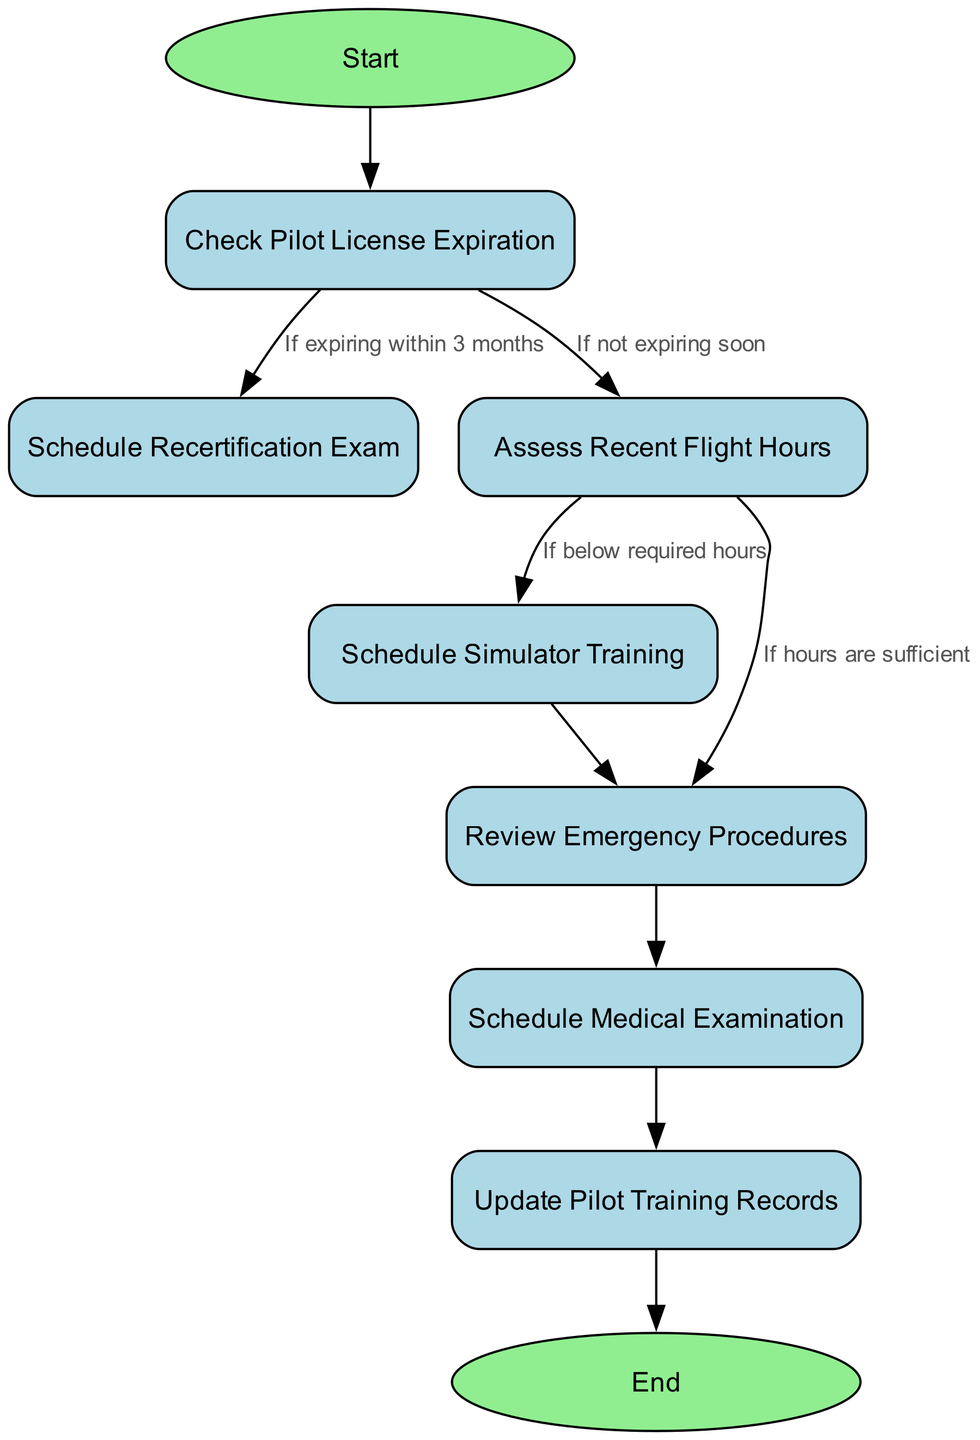What is the first step in the flowchart? The starting point of the flowchart is represented by the "Start" node, which indicates the initiation of the pilot recertification and ongoing training program scheduling process.
Answer: Start How many nodes are in the diagram? By counting all the nodes including the start and end nodes, there are a total of nine nodes in the diagram.
Answer: Nine What does the "Check Pilot License Expiration" node lead to if the license is expiring soon? If the pilot license is expiring soon, the next step to follow is the "Schedule Recertification Exam" node, based on the flow from the license check node.
Answer: Schedule Recertification Exam What is the outcome if the pilot has sufficient flight hours? If the pilot has sufficient flight hours, the process moves to the "Review Emergency Procedures" node without scheduling simulator training.
Answer: Review Emergency Procedures What is the last step of the flowchart? The final step of the flowchart, marked by the end node, is to conclude the recertification and training process after updating pilot training records.
Answer: End What happens after reviewing emergency procedures? After reviewing emergency procedures, the next step is to "Schedule Medical Examination," indicating that medical checks are a necessary part of the procedure.
Answer: Schedule Medical Examination If a pilot has insufficient flight hours, what is the next step? If the pilot has insufficient flight hours, the flowchart indicates that the next step would be to "Schedule Simulator Training," emphasizing the need for additional training.
Answer: Schedule Simulator Training How many edges are in the flowchart? By analyzing the connections between the nodes, we see there are a total of eight edges that define the flow of actions within the diagram.
Answer: Eight What does the "Schedule Medical Examination" lead to? After scheduling a medical examination, the flow proceeds to "Update Pilot Training Records," showing that recordkeeping is a follow-up action to medical checks.
Answer: Update Pilot Training Records 